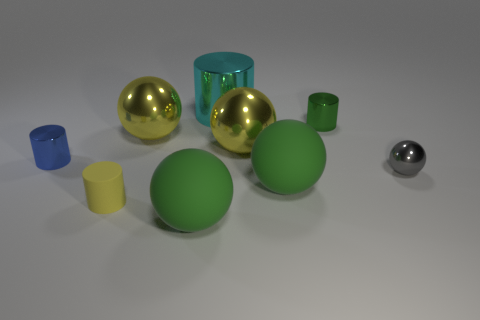What size is the green thing that is behind the small shiny thing in front of the small blue object?
Make the answer very short. Small. There is a large sphere that is both in front of the small blue metal thing and behind the yellow matte cylinder; what is its material?
Provide a succinct answer. Rubber. Is there any other thing that has the same color as the large shiny cylinder?
Offer a very short reply. No. Are there fewer small metal spheres in front of the rubber cylinder than green metallic objects?
Offer a terse response. Yes. Are there more green matte things than rubber objects?
Your response must be concise. No. Are there any big green matte balls to the right of the rubber sphere that is to the left of the matte sphere to the right of the big metal cylinder?
Provide a short and direct response. Yes. What number of other things are there of the same size as the blue metallic cylinder?
Your answer should be very brief. 3. There is a gray ball; are there any big cyan metallic cylinders in front of it?
Ensure brevity in your answer.  No. There is a tiny matte thing; is its color the same as the large metal ball that is to the right of the cyan cylinder?
Give a very brief answer. Yes. There is a big rubber sphere that is in front of the tiny yellow matte cylinder that is in front of the shiny object behind the green metallic cylinder; what is its color?
Your answer should be very brief. Green. 